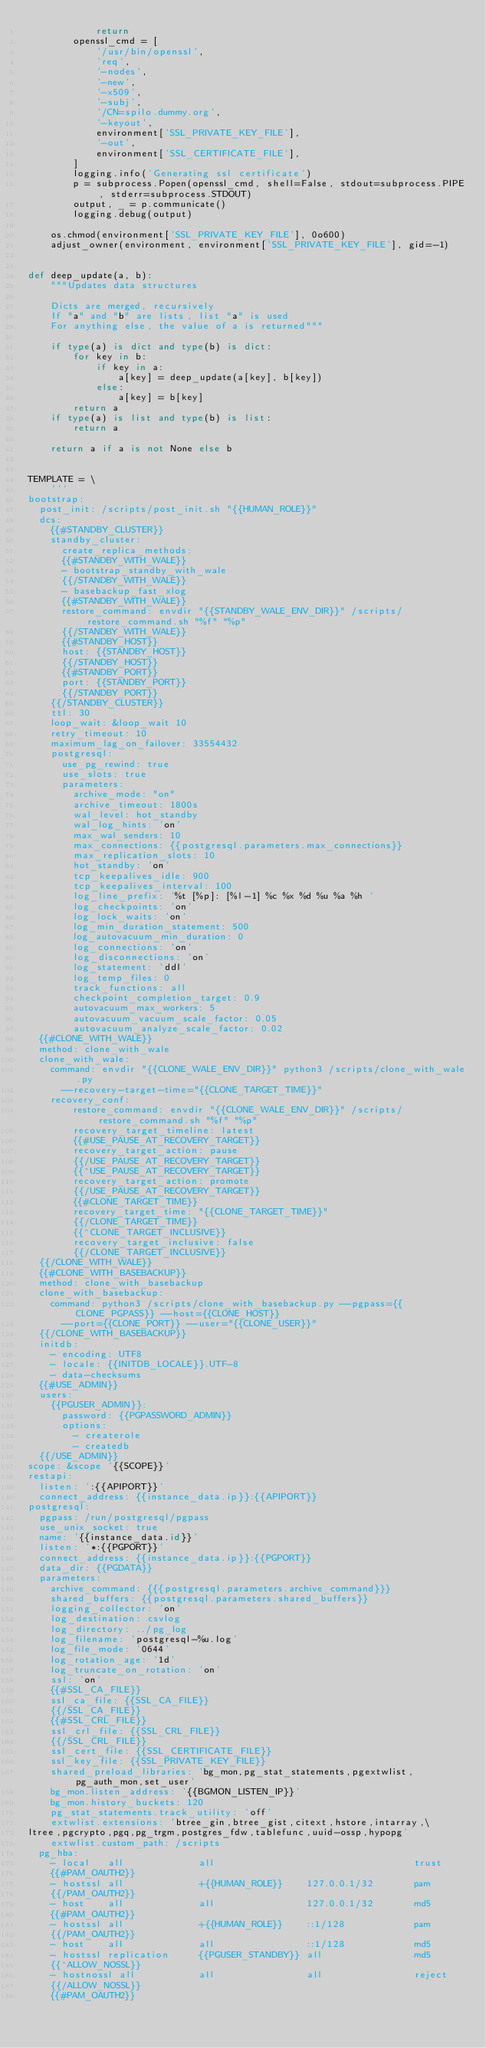<code> <loc_0><loc_0><loc_500><loc_500><_Python_>            return
        openssl_cmd = [
            '/usr/bin/openssl',
            'req',
            '-nodes',
            '-new',
            '-x509',
            '-subj',
            '/CN=spilo.dummy.org',
            '-keyout',
            environment['SSL_PRIVATE_KEY_FILE'],
            '-out',
            environment['SSL_CERTIFICATE_FILE'],
        ]
        logging.info('Generating ssl certificate')
        p = subprocess.Popen(openssl_cmd, shell=False, stdout=subprocess.PIPE, stderr=subprocess.STDOUT)
        output, _ = p.communicate()
        logging.debug(output)

    os.chmod(environment['SSL_PRIVATE_KEY_FILE'], 0o600)
    adjust_owner(environment, environment['SSL_PRIVATE_KEY_FILE'], gid=-1)


def deep_update(a, b):
    """Updates data structures

    Dicts are merged, recursively
    If "a" and "b" are lists, list "a" is used
    For anything else, the value of a is returned"""

    if type(a) is dict and type(b) is dict:
        for key in b:
            if key in a:
                a[key] = deep_update(a[key], b[key])
            else:
                a[key] = b[key]
        return a
    if type(a) is list and type(b) is list:
        return a

    return a if a is not None else b


TEMPLATE = \
    '''
bootstrap:
  post_init: /scripts/post_init.sh "{{HUMAN_ROLE}}"
  dcs:
    {{#STANDBY_CLUSTER}}
    standby_cluster:
      create_replica_methods:
      {{#STANDBY_WITH_WALE}}
      - bootstrap_standby_with_wale
      {{/STANDBY_WITH_WALE}}
      - basebackup_fast_xlog
      {{#STANDBY_WITH_WALE}}
      restore_command: envdir "{{STANDBY_WALE_ENV_DIR}}" /scripts/restore_command.sh "%f" "%p"
      {{/STANDBY_WITH_WALE}}
      {{#STANDBY_HOST}}
      host: {{STANDBY_HOST}}
      {{/STANDBY_HOST}}
      {{#STANDBY_PORT}}
      port: {{STANDBY_PORT}}
      {{/STANDBY_PORT}}
    {{/STANDBY_CLUSTER}}
    ttl: 30
    loop_wait: &loop_wait 10
    retry_timeout: 10
    maximum_lag_on_failover: 33554432
    postgresql:
      use_pg_rewind: true
      use_slots: true
      parameters:
        archive_mode: "on"
        archive_timeout: 1800s
        wal_level: hot_standby
        wal_log_hints: 'on'
        max_wal_senders: 10
        max_connections: {{postgresql.parameters.max_connections}}
        max_replication_slots: 10
        hot_standby: 'on'
        tcp_keepalives_idle: 900
        tcp_keepalives_interval: 100
        log_line_prefix: '%t [%p]: [%l-1] %c %x %d %u %a %h '
        log_checkpoints: 'on'
        log_lock_waits: 'on'
        log_min_duration_statement: 500
        log_autovacuum_min_duration: 0
        log_connections: 'on'
        log_disconnections: 'on'
        log_statement: 'ddl'
        log_temp_files: 0
        track_functions: all
        checkpoint_completion_target: 0.9
        autovacuum_max_workers: 5
        autovacuum_vacuum_scale_factor: 0.05
        autovacuum_analyze_scale_factor: 0.02
  {{#CLONE_WITH_WALE}}
  method: clone_with_wale
  clone_with_wale:
    command: envdir "{{CLONE_WALE_ENV_DIR}}" python3 /scripts/clone_with_wale.py
      --recovery-target-time="{{CLONE_TARGET_TIME}}"
    recovery_conf:
        restore_command: envdir "{{CLONE_WALE_ENV_DIR}}" /scripts/restore_command.sh "%f" "%p"
        recovery_target_timeline: latest
        {{#USE_PAUSE_AT_RECOVERY_TARGET}}
        recovery_target_action: pause
        {{/USE_PAUSE_AT_RECOVERY_TARGET}}
        {{^USE_PAUSE_AT_RECOVERY_TARGET}}
        recovery_target_action: promote
        {{/USE_PAUSE_AT_RECOVERY_TARGET}}
        {{#CLONE_TARGET_TIME}}
        recovery_target_time: "{{CLONE_TARGET_TIME}}"
        {{/CLONE_TARGET_TIME}}
        {{^CLONE_TARGET_INCLUSIVE}}
        recovery_target_inclusive: false
        {{/CLONE_TARGET_INCLUSIVE}}
  {{/CLONE_WITH_WALE}}
  {{#CLONE_WITH_BASEBACKUP}}
  method: clone_with_basebackup
  clone_with_basebackup:
    command: python3 /scripts/clone_with_basebackup.py --pgpass={{CLONE_PGPASS}} --host={{CLONE_HOST}}
      --port={{CLONE_PORT}} --user="{{CLONE_USER}}"
  {{/CLONE_WITH_BASEBACKUP}}
  initdb:
    - encoding: UTF8
    - locale: {{INITDB_LOCALE}}.UTF-8
    - data-checksums
  {{#USE_ADMIN}}
  users:
    {{PGUSER_ADMIN}}:
      password: {{PGPASSWORD_ADMIN}}
      options:
        - createrole
        - createdb
  {{/USE_ADMIN}}
scope: &scope '{{SCOPE}}'
restapi:
  listen: ':{{APIPORT}}'
  connect_address: {{instance_data.ip}}:{{APIPORT}}
postgresql:
  pgpass: /run/postgresql/pgpass
  use_unix_socket: true
  name: '{{instance_data.id}}'
  listen: '*:{{PGPORT}}'
  connect_address: {{instance_data.ip}}:{{PGPORT}}
  data_dir: {{PGDATA}}
  parameters:
    archive_command: {{{postgresql.parameters.archive_command}}}
    shared_buffers: {{postgresql.parameters.shared_buffers}}
    logging_collector: 'on'
    log_destination: csvlog
    log_directory: ../pg_log
    log_filename: 'postgresql-%u.log'
    log_file_mode: '0644'
    log_rotation_age: '1d'
    log_truncate_on_rotation: 'on'
    ssl: 'on'
    {{#SSL_CA_FILE}}
    ssl_ca_file: {{SSL_CA_FILE}}
    {{/SSL_CA_FILE}}
    {{#SSL_CRL_FILE}}
    ssl_crl_file: {{SSL_CRL_FILE}}
    {{/SSL_CRL_FILE}}
    ssl_cert_file: {{SSL_CERTIFICATE_FILE}}
    ssl_key_file: {{SSL_PRIVATE_KEY_FILE}}
    shared_preload_libraries: 'bg_mon,pg_stat_statements,pgextwlist,pg_auth_mon,set_user'
    bg_mon.listen_address: '{{BGMON_LISTEN_IP}}'
    bg_mon.history_buckets: 120
    pg_stat_statements.track_utility: 'off'
    extwlist.extensions: 'btree_gin,btree_gist,citext,hstore,intarray,\
ltree,pgcrypto,pgq,pg_trgm,postgres_fdw,tablefunc,uuid-ossp,hypopg'
    extwlist.custom_path: /scripts
  pg_hba:
    - local   all             all                                   trust
    {{#PAM_OAUTH2}}
    - hostssl all             +{{HUMAN_ROLE}}    127.0.0.1/32       pam
    {{/PAM_OAUTH2}}
    - host    all             all                127.0.0.1/32       md5
    {{#PAM_OAUTH2}}
    - hostssl all             +{{HUMAN_ROLE}}    ::1/128            pam
    {{/PAM_OAUTH2}}
    - host    all             all                ::1/128            md5
    - hostssl replication     {{PGUSER_STANDBY}} all                md5
    {{^ALLOW_NOSSL}}
    - hostnossl all           all                all                reject
    {{/ALLOW_NOSSL}}
    {{#PAM_OAUTH2}}</code> 